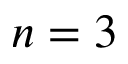Convert formula to latex. <formula><loc_0><loc_0><loc_500><loc_500>n = 3</formula> 